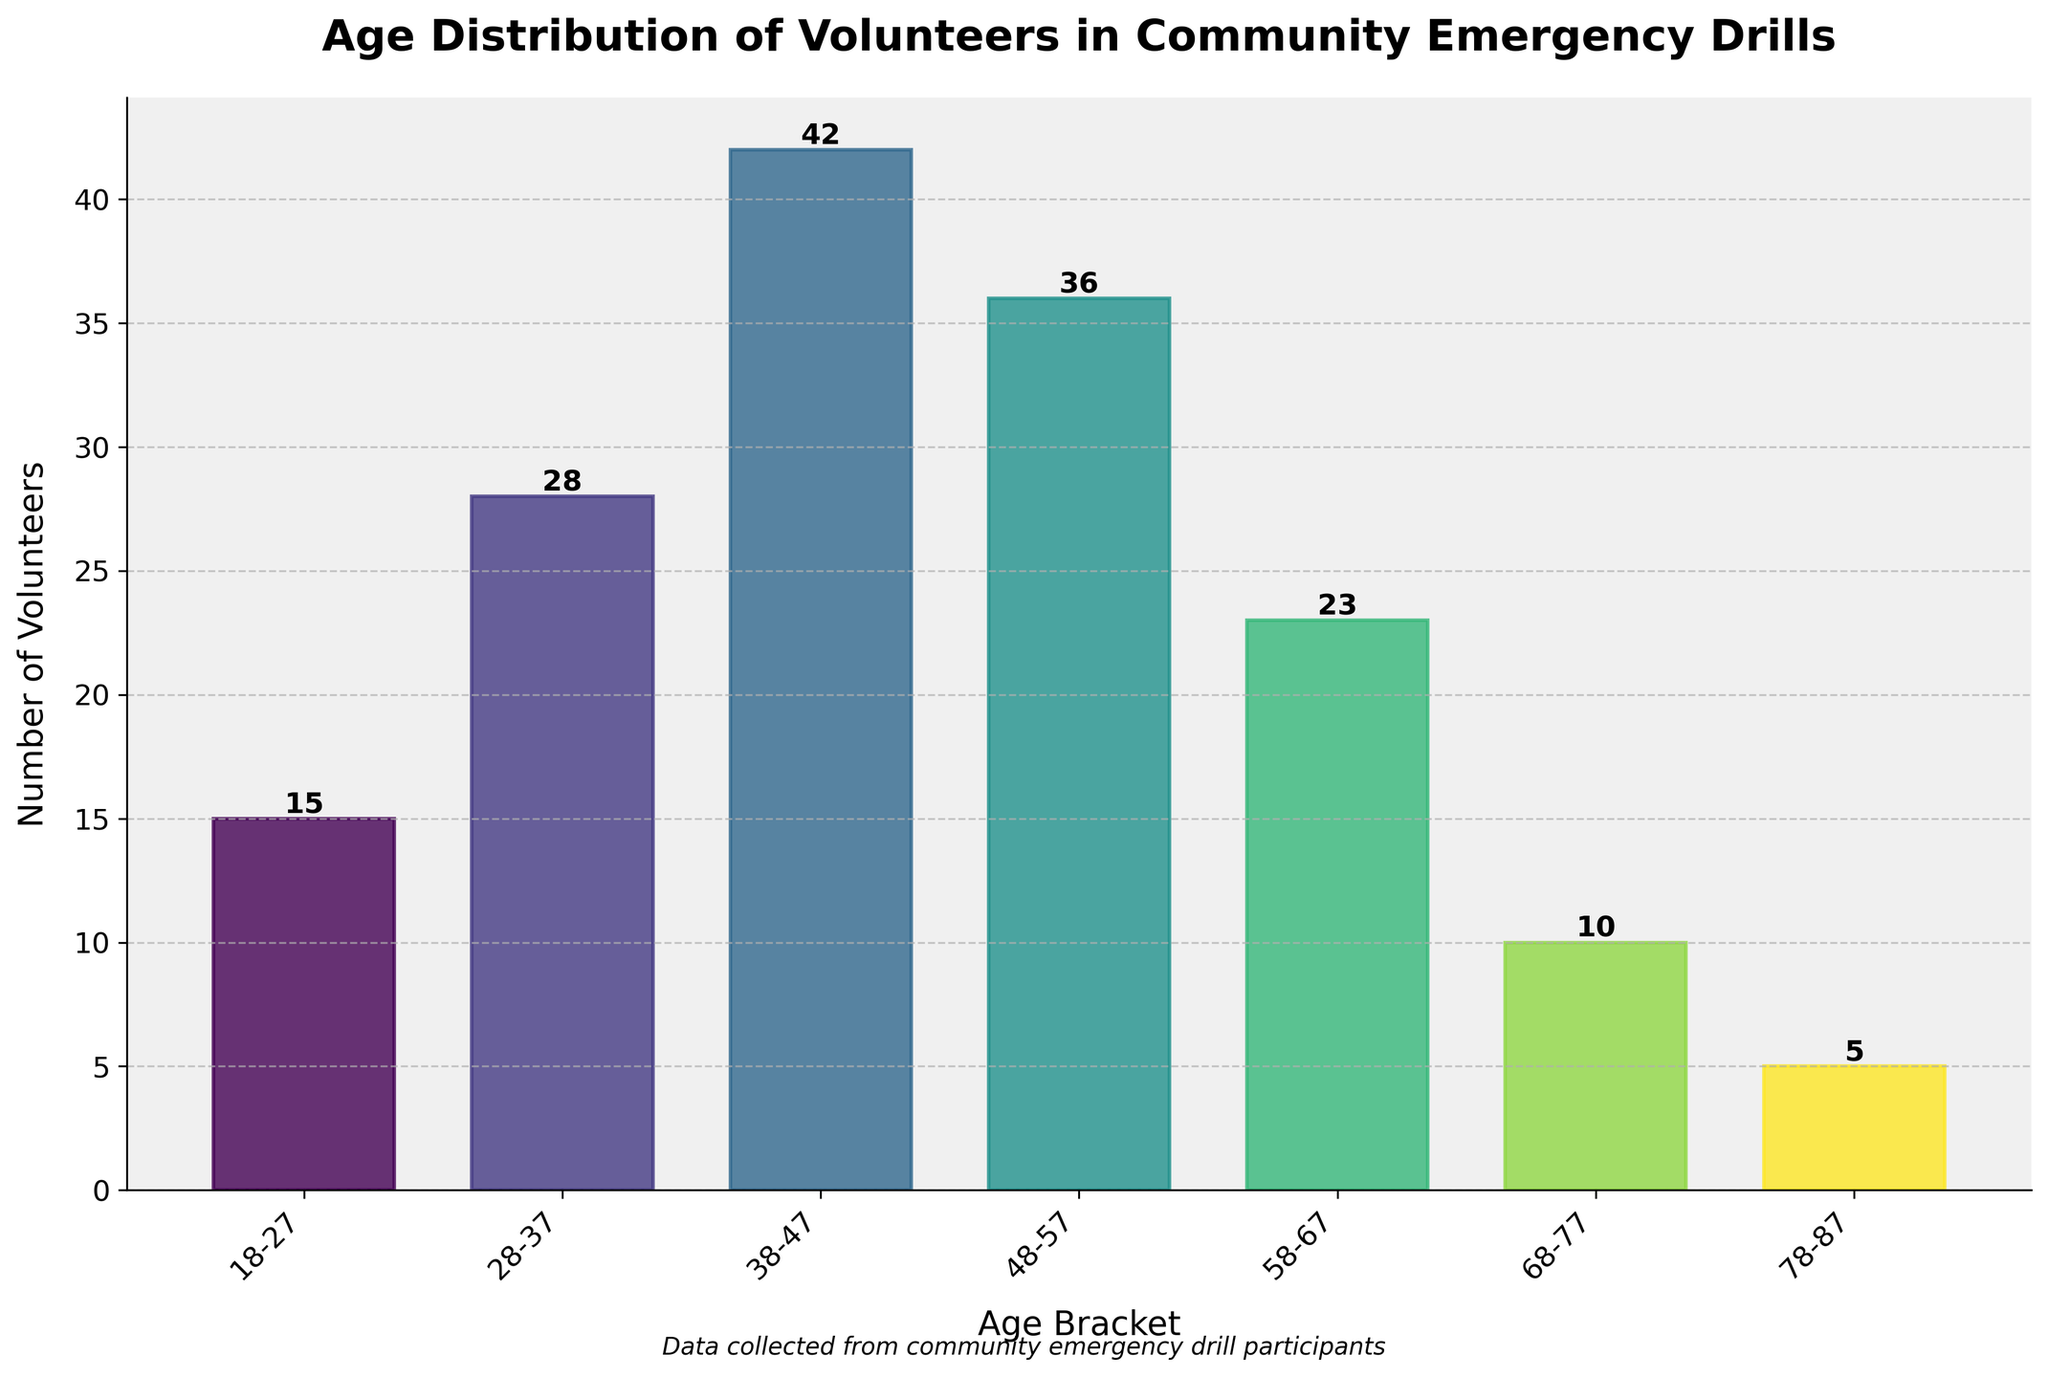What's the title of the plot? The title is shown at the top of the plot.
Answer: Age Distribution of Volunteers in Community Emergency Drills What is the age bracket with the highest number of volunteers? Locate the tallest bar in the histogram to determine the age bracket with the highest number.
Answer: 38-47 How many volunteers are there in the 58-67 age bracket? Refer to the numerical value at the top of the bar corresponding to the 58-67 age bracket.
Answer: 23 What is the total number of volunteers participating in the drills? Sum the number of volunteers in each age bracket: 15 + 28 + 42 + 36 + 23 + 10 + 5.
Answer: 159 Which age bracket has fewer volunteers, 48-57 or 68-77? Compare the heights of the bars corresponding to the 48-57 and 68-77 age brackets.
Answer: 68-77 By how much does the number of volunteers in the 38-47 age bracket exceed those in the 18-27 age bracket? Subtract the number of volunteers in the 18-27 age bracket from the number in the 38-47 age bracket: 42 - 15.
Answer: 27 How does the number of volunteers in the 78-87 age bracket compare to those in the 48-57 age bracket? Compare the heights of the bars for the 78-87 and 48-57 age brackets to see which is taller.
Answer: Less What is the average number of volunteers per age bracket? Divide the total number of volunteers by the number of age brackets: 159 / 7.
Answer: Approximately 22.71 What is the age bracket with the lowest number of volunteers? Look for the shortest bar in the histogram to find the age bracket with the lowest number.
Answer: 78-87 Is the distribution of volunteers across age brackets uniform or skewed? Analyze the varying heights of the bars to determine whether the distribution is skewed toward certain age brackets.
Answer: Skewed 